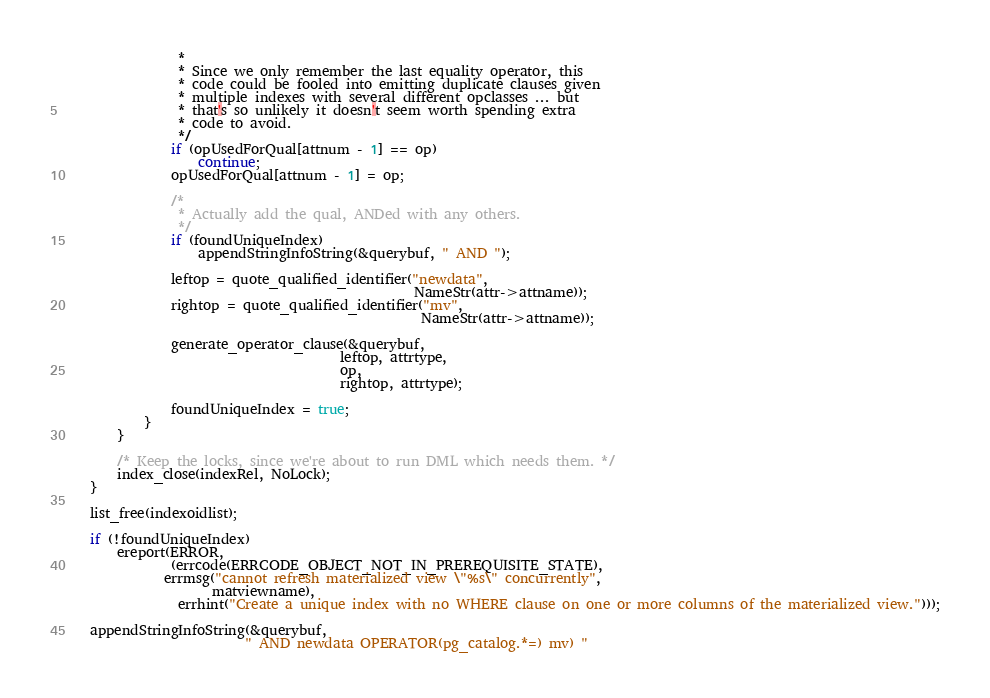<code> <loc_0><loc_0><loc_500><loc_500><_C_>				 *
				 * Since we only remember the last equality operator, this
				 * code could be fooled into emitting duplicate clauses given
				 * multiple indexes with several different opclasses ... but
				 * that's so unlikely it doesn't seem worth spending extra
				 * code to avoid.
				 */
				if (opUsedForQual[attnum - 1] == op)
					continue;
				opUsedForQual[attnum - 1] = op;

				/*
				 * Actually add the qual, ANDed with any others.
				 */
				if (foundUniqueIndex)
					appendStringInfoString(&querybuf, " AND ");

				leftop = quote_qualified_identifier("newdata",
													NameStr(attr->attname));
				rightop = quote_qualified_identifier("mv",
													 NameStr(attr->attname));

				generate_operator_clause(&querybuf,
										 leftop, attrtype,
										 op,
										 rightop, attrtype);

				foundUniqueIndex = true;
			}
		}

		/* Keep the locks, since we're about to run DML which needs them. */
		index_close(indexRel, NoLock);
	}

	list_free(indexoidlist);

	if (!foundUniqueIndex)
		ereport(ERROR,
				(errcode(ERRCODE_OBJECT_NOT_IN_PREREQUISITE_STATE),
			   errmsg("cannot refresh materialized view \"%s\" concurrently",
					  matviewname),
				 errhint("Create a unique index with no WHERE clause on one or more columns of the materialized view.")));

	appendStringInfoString(&querybuf,
						   " AND newdata OPERATOR(pg_catalog.*=) mv) "</code> 